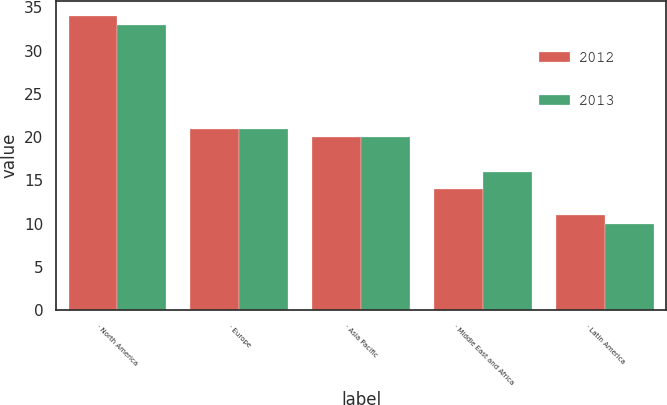Convert chart. <chart><loc_0><loc_0><loc_500><loc_500><stacked_bar_chart><ecel><fcel>· North America<fcel>· Europe<fcel>· Asia Pacific<fcel>· Middle East and Africa<fcel>· Latin America<nl><fcel>2012<fcel>34<fcel>21<fcel>20<fcel>14<fcel>11<nl><fcel>2013<fcel>33<fcel>21<fcel>20<fcel>16<fcel>10<nl></chart> 